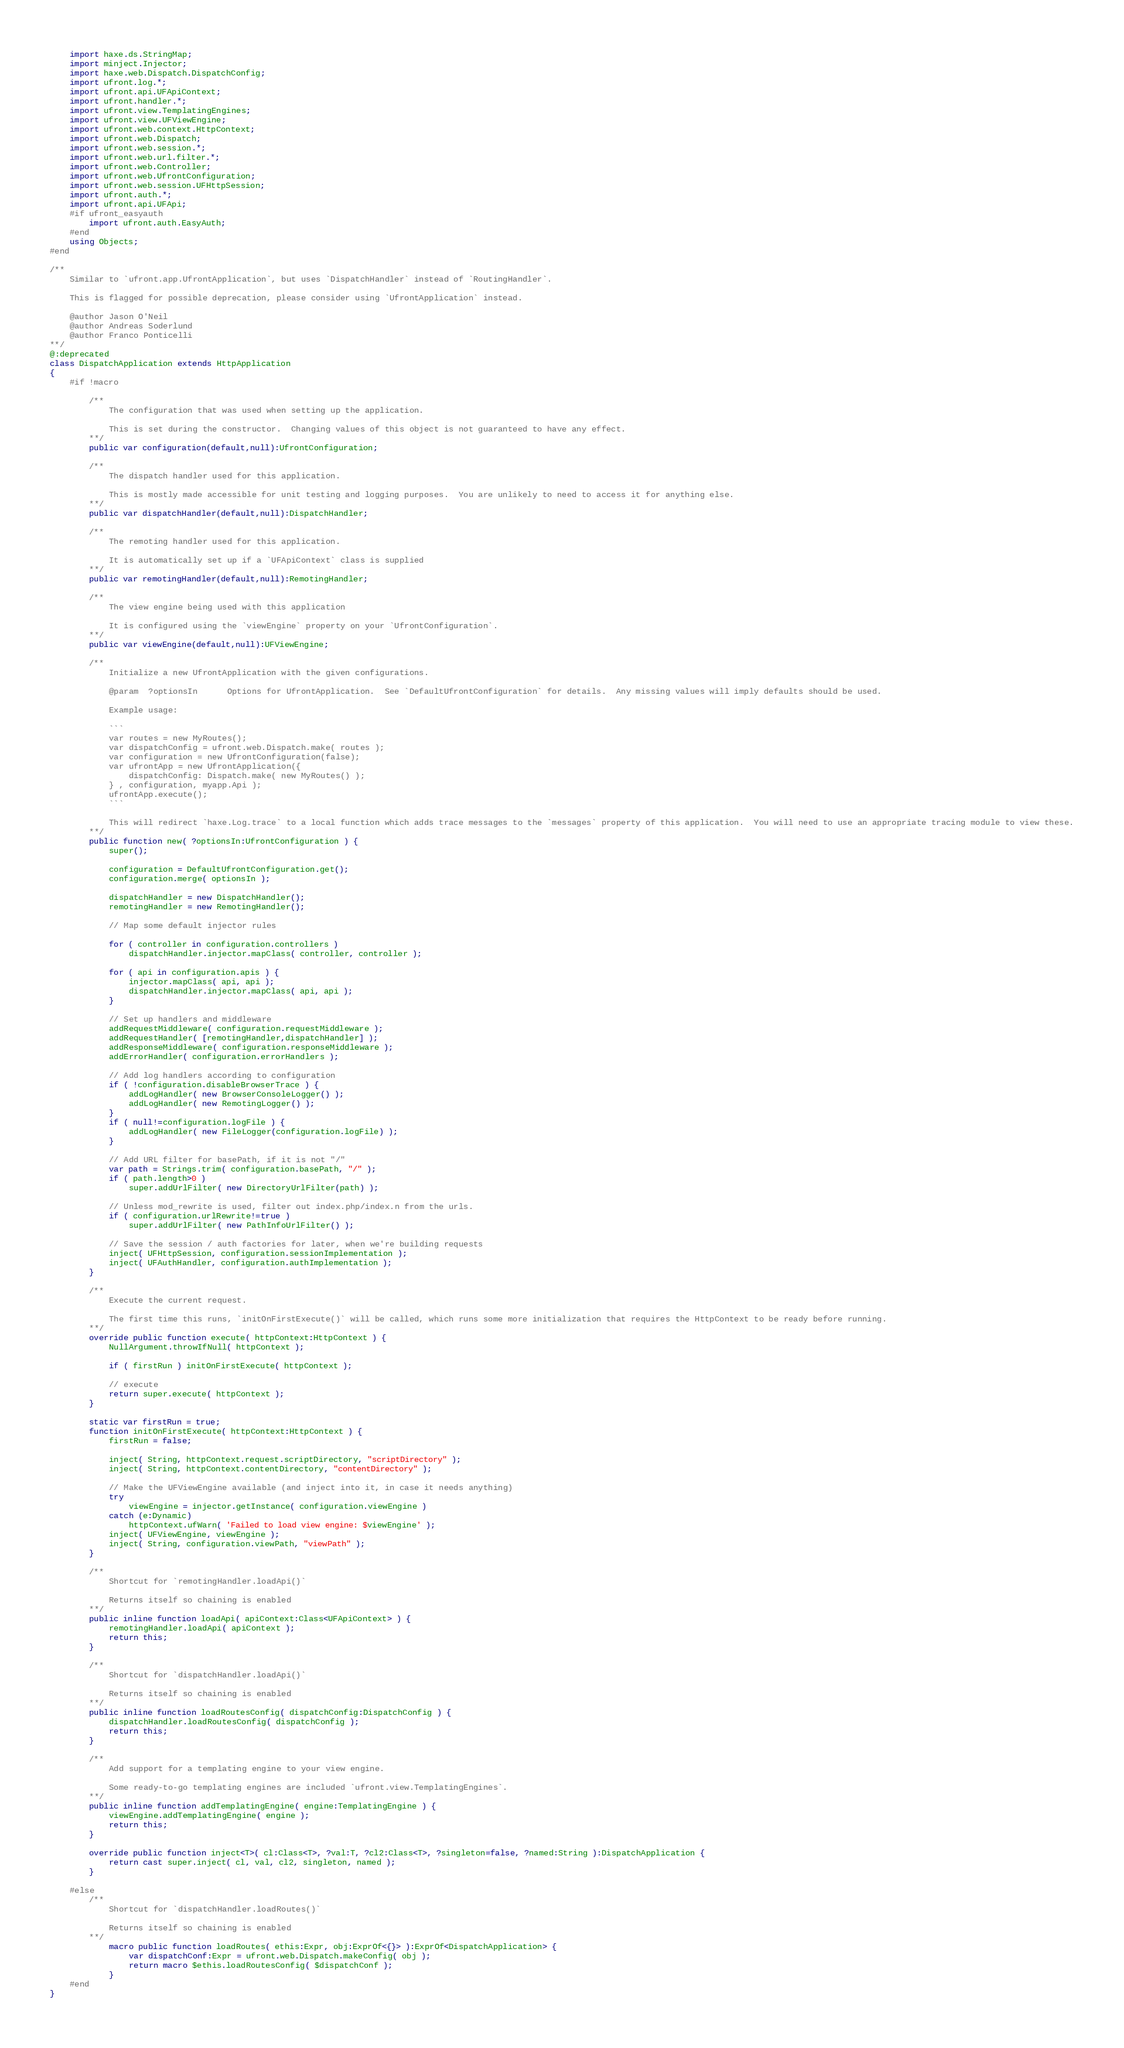<code> <loc_0><loc_0><loc_500><loc_500><_Haxe_>	import haxe.ds.StringMap;
	import minject.Injector;
	import haxe.web.Dispatch.DispatchConfig;
	import ufront.log.*;
	import ufront.api.UFApiContext;
	import ufront.handler.*;
	import ufront.view.TemplatingEngines;
	import ufront.view.UFViewEngine;
	import ufront.web.context.HttpContext;
	import ufront.web.Dispatch;
	import ufront.web.session.*;
	import ufront.web.url.filter.*;
	import ufront.web.Controller;
	import ufront.web.UfrontConfiguration;
	import ufront.web.session.UFHttpSession;
	import ufront.auth.*;
	import ufront.api.UFApi;
	#if ufront_easyauth
		import ufront.auth.EasyAuth;
	#end
	using Objects;
#end

/**
	Similar to `ufront.app.UfrontApplication`, but uses `DispatchHandler` instead of `RoutingHandler`.

	This is flagged for possible deprecation, please consider using `UfrontApplication` instead.

	@author Jason O'Neil
	@author Andreas Soderlund
	@author Franco Ponticelli
**/
@:deprecated
class DispatchApplication extends HttpApplication
{
	#if !macro

		/**
			The configuration that was used when setting up the application.

			This is set during the constructor.  Changing values of this object is not guaranteed to have any effect.
		**/
		public var configuration(default,null):UfrontConfiguration;

		/**
			The dispatch handler used for this application.

			This is mostly made accessible for unit testing and logging purposes.  You are unlikely to need to access it for anything else.
		**/
		public var dispatchHandler(default,null):DispatchHandler;

		/**
			The remoting handler used for this application.

			It is automatically set up if a `UFApiContext` class is supplied
		**/
		public var remotingHandler(default,null):RemotingHandler;

		/**
			The view engine being used with this application

			It is configured using the `viewEngine` property on your `UfrontConfiguration`.
		**/
		public var viewEngine(default,null):UFViewEngine;

		/**
			Initialize a new UfrontApplication with the given configurations.

			@param	?optionsIn		Options for UfrontApplication.  See `DefaultUfrontConfiguration` for details.  Any missing values will imply defaults should be used.

			Example usage:

			```
			var routes = new MyRoutes();
			var dispatchConfig = ufront.web.Dispatch.make( routes );
			var configuration = new UfrontConfiguration(false);
			var ufrontApp = new UfrontApplication({
				dispatchConfig: Dispatch.make( new MyRoutes() );
			} , configuration, myapp.Api );
			ufrontApp.execute();
			```

			This will redirect `haxe.Log.trace` to a local function which adds trace messages to the `messages` property of this application.  You will need to use an appropriate tracing module to view these.
		**/
		public function new( ?optionsIn:UfrontConfiguration ) {
			super();

			configuration = DefaultUfrontConfiguration.get();
			configuration.merge( optionsIn );

			dispatchHandler = new DispatchHandler();
			remotingHandler = new RemotingHandler();

			// Map some default injector rules

			for ( controller in configuration.controllers )
				dispatchHandler.injector.mapClass( controller, controller );

			for ( api in configuration.apis ) {
				injector.mapClass( api, api );
				dispatchHandler.injector.mapClass( api, api );
			}

			// Set up handlers and middleware
			addRequestMiddleware( configuration.requestMiddleware );
			addRequestHandler( [remotingHandler,dispatchHandler] );
			addResponseMiddleware( configuration.responseMiddleware );
			addErrorHandler( configuration.errorHandlers );

			// Add log handlers according to configuration
			if ( !configuration.disableBrowserTrace ) {
				addLogHandler( new BrowserConsoleLogger() );
				addLogHandler( new RemotingLogger() );
			}
			if ( null!=configuration.logFile ) {
				addLogHandler( new FileLogger(configuration.logFile) );
			}

			// Add URL filter for basePath, if it is not "/"
			var path = Strings.trim( configuration.basePath, "/" );
			if ( path.length>0 )
				super.addUrlFilter( new DirectoryUrlFilter(path) );

			// Unless mod_rewrite is used, filter out index.php/index.n from the urls.
			if ( configuration.urlRewrite!=true )
				super.addUrlFilter( new PathInfoUrlFilter() );

			// Save the session / auth factories for later, when we're building requests
			inject( UFHttpSession, configuration.sessionImplementation );
			inject( UFAuthHandler, configuration.authImplementation );
		}

		/**
			Execute the current request.

			The first time this runs, `initOnFirstExecute()` will be called, which runs some more initialization that requires the HttpContext to be ready before running.
		**/
		override public function execute( httpContext:HttpContext ) {
			NullArgument.throwIfNull( httpContext );

			if ( firstRun ) initOnFirstExecute( httpContext );

			// execute
			return super.execute( httpContext );
		}

		static var firstRun = true;
		function initOnFirstExecute( httpContext:HttpContext ) {
			firstRun = false;

			inject( String, httpContext.request.scriptDirectory, "scriptDirectory" );
			inject( String, httpContext.contentDirectory, "contentDirectory" );

			// Make the UFViewEngine available (and inject into it, in case it needs anything)
			try
				viewEngine = injector.getInstance( configuration.viewEngine )
			catch (e:Dynamic)
				httpContext.ufWarn( 'Failed to load view engine: $viewEngine' );
			inject( UFViewEngine, viewEngine );
			inject( String, configuration.viewPath, "viewPath" );
		}

		/**
			Shortcut for `remotingHandler.loadApi()`

			Returns itself so chaining is enabled
		**/
		public inline function loadApi( apiContext:Class<UFApiContext> ) {
			remotingHandler.loadApi( apiContext );
			return this;
		}

		/**
			Shortcut for `dispatchHandler.loadApi()`

			Returns itself so chaining is enabled
		**/
		public inline function loadRoutesConfig( dispatchConfig:DispatchConfig ) {
			dispatchHandler.loadRoutesConfig( dispatchConfig );
			return this;
		}

		/**
			Add support for a templating engine to your view engine.

			Some ready-to-go templating engines are included `ufront.view.TemplatingEngines`.
		**/
		public inline function addTemplatingEngine( engine:TemplatingEngine ) {
			viewEngine.addTemplatingEngine( engine );
			return this;
		}

		override public function inject<T>( cl:Class<T>, ?val:T, ?cl2:Class<T>, ?singleton=false, ?named:String ):DispatchApplication {
			return cast super.inject( cl, val, cl2, singleton, named );
		}

	#else
		/**
			Shortcut for `dispatchHandler.loadRoutes()`

			Returns itself so chaining is enabled
		**/
			macro public function loadRoutes( ethis:Expr, obj:ExprOf<{}> ):ExprOf<DispatchApplication> {
				var dispatchConf:Expr = ufront.web.Dispatch.makeConfig( obj );
				return macro $ethis.loadRoutesConfig( $dispatchConf );
			}
	#end
}
</code> 